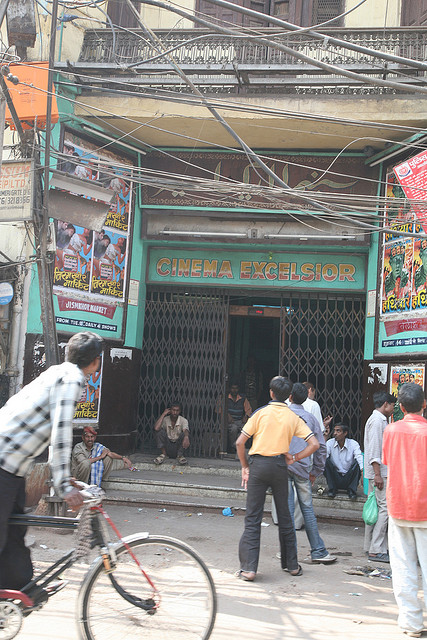How might this cinema be different from a modern multiplex theater? 'CINEMA EXCELSIOR' likely offers a stark contrast to a modern multiplex theater. Unlike the sleek, high-tech environments of modern cineplexes, this cinema carries a rustic, old-world charm with its vintage facade and metal grill gate. The overall ambiance feels more personal and nostalgic, evoking memories of simpler times. It might lack advanced amenities like reclining seats, surround sound, or digital projectors, instead offering a more traditional and communal viewing experience. The posters and the eclectic mix of movies reflect local tastes and cultural significance, making it a unique and cherished venue compared to the standardized, high-efficiency settings of modern theaters. 